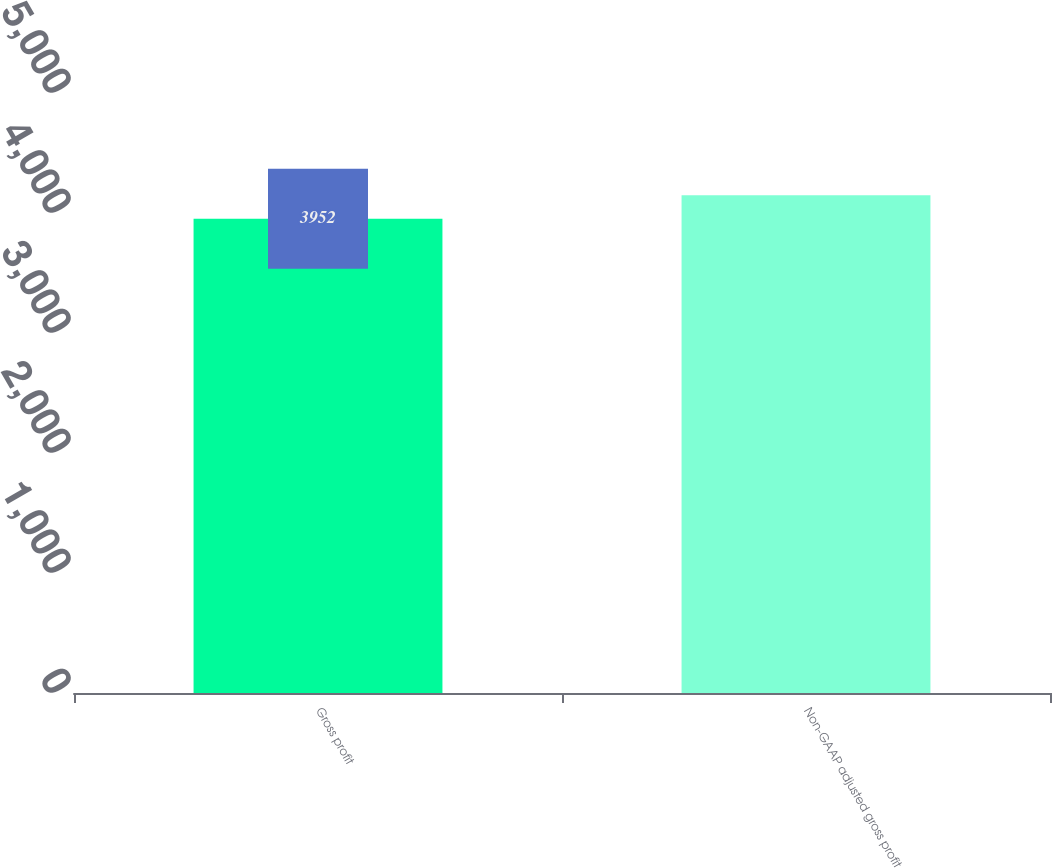<chart> <loc_0><loc_0><loc_500><loc_500><bar_chart><fcel>Gross profit<fcel>Non-GAAP adjusted gross profit<nl><fcel>3952<fcel>4147<nl></chart> 